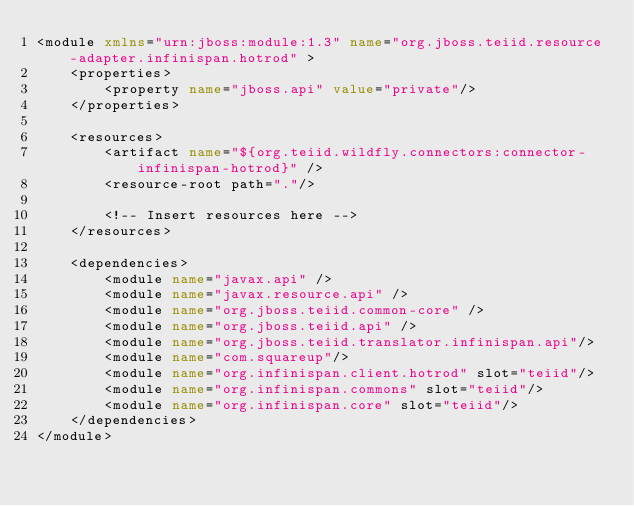Convert code to text. <code><loc_0><loc_0><loc_500><loc_500><_XML_><module xmlns="urn:jboss:module:1.3" name="org.jboss.teiid.resource-adapter.infinispan.hotrod" >
    <properties>
        <property name="jboss.api" value="private"/>
    </properties>
    
    <resources>
        <artifact name="${org.teiid.wildfly.connectors:connector-infinispan-hotrod}" />
        <resource-root path="."/>

        <!-- Insert resources here -->
    </resources>

    <dependencies>
        <module name="javax.api" />
        <module name="javax.resource.api" />
        <module name="org.jboss.teiid.common-core" />
        <module name="org.jboss.teiid.api" />    
        <module name="org.jboss.teiid.translator.infinispan.api"/>  
        <module name="com.squareup"/> 				
        <module name="org.infinispan.client.hotrod" slot="teiid"/>
        <module name="org.infinispan.commons" slot="teiid"/>
        <module name="org.infinispan.core" slot="teiid"/>
    </dependencies>
</module>
</code> 